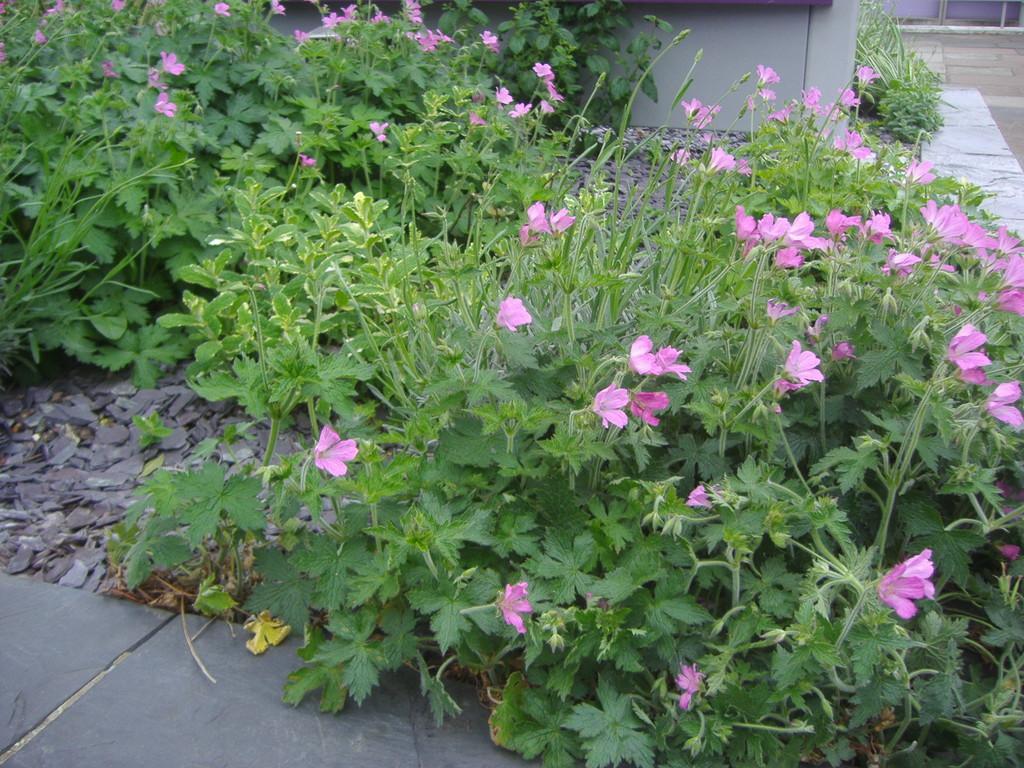Could you give a brief overview of what you see in this image? In this image we can see pink color flower plants on the land. At the top of the image, we can see pavement and an object. 